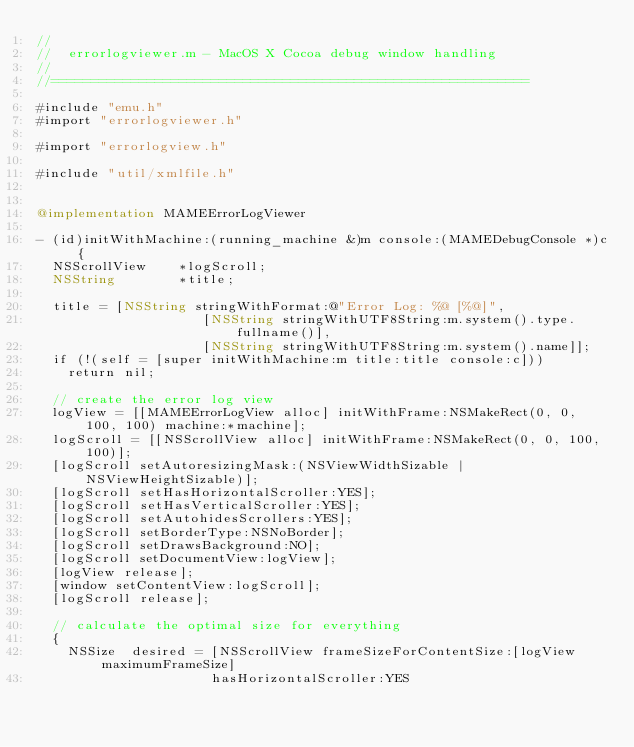<code> <loc_0><loc_0><loc_500><loc_500><_ObjectiveC_>//
//  errorlogviewer.m - MacOS X Cocoa debug window handling
//
//============================================================

#include "emu.h"
#import "errorlogviewer.h"

#import "errorlogview.h"

#include "util/xmlfile.h"


@implementation MAMEErrorLogViewer

- (id)initWithMachine:(running_machine &)m console:(MAMEDebugConsole *)c {
	NSScrollView    *logScroll;
	NSString        *title;

	title = [NSString stringWithFormat:@"Error Log: %@ [%@]",
									   [NSString stringWithUTF8String:m.system().type.fullname()],
									   [NSString stringWithUTF8String:m.system().name]];
	if (!(self = [super initWithMachine:m title:title console:c]))
		return nil;

	// create the error log view
	logView = [[MAMEErrorLogView alloc] initWithFrame:NSMakeRect(0, 0, 100, 100) machine:*machine];
	logScroll = [[NSScrollView alloc] initWithFrame:NSMakeRect(0, 0, 100, 100)];
	[logScroll setAutoresizingMask:(NSViewWidthSizable | NSViewHeightSizable)];
	[logScroll setHasHorizontalScroller:YES];
	[logScroll setHasVerticalScroller:YES];
	[logScroll setAutohidesScrollers:YES];
	[logScroll setBorderType:NSNoBorder];
	[logScroll setDrawsBackground:NO];
	[logScroll setDocumentView:logView];
	[logView release];
	[window setContentView:logScroll];
	[logScroll release];

	// calculate the optimal size for everything
	{
		NSSize  desired = [NSScrollView frameSizeForContentSize:[logView maximumFrameSize]
										  hasHorizontalScroller:YES</code> 